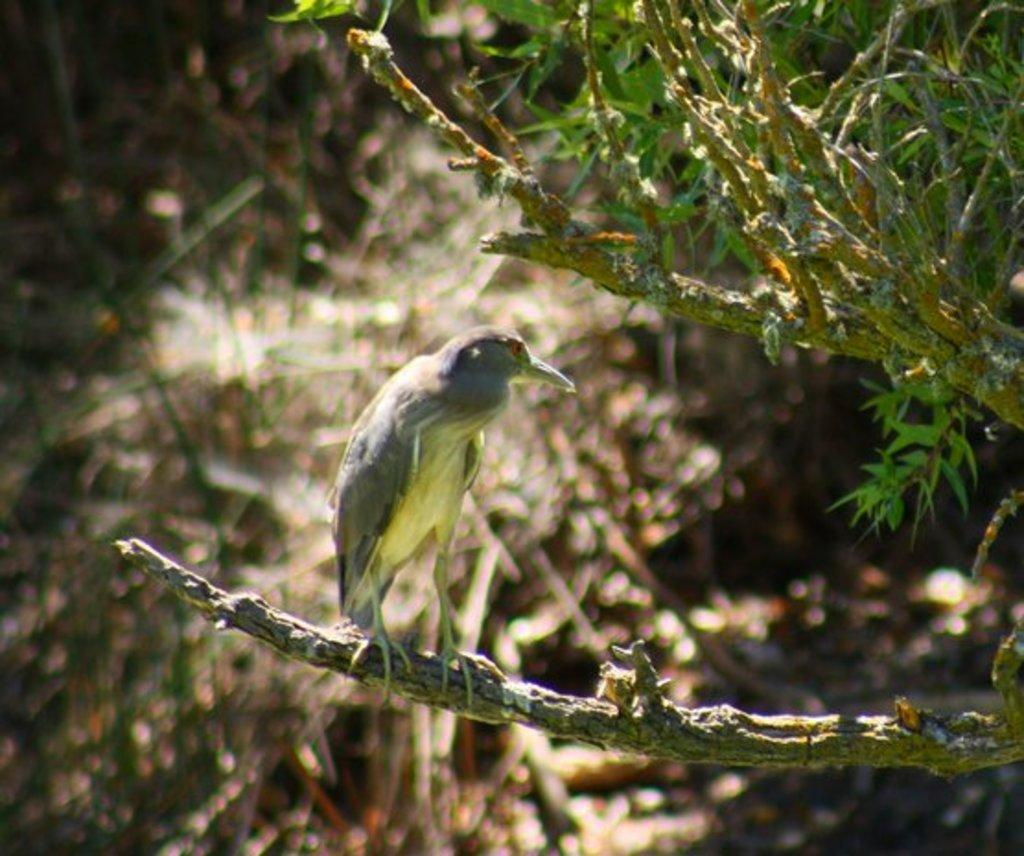What type of animal can be seen in the image? There is a bird in the image. Where is the bird located? The bird is on a branch. What else can be seen in the image besides the bird? There are leaves in the image. Can you describe the background of the image? The background of the image is blurred. How many chairs are visible in the image? There are no chairs present in the image. What type of wilderness can be seen in the image? There is no wilderness depicted in the image; it features a bird on a branch with leaves in the background. 